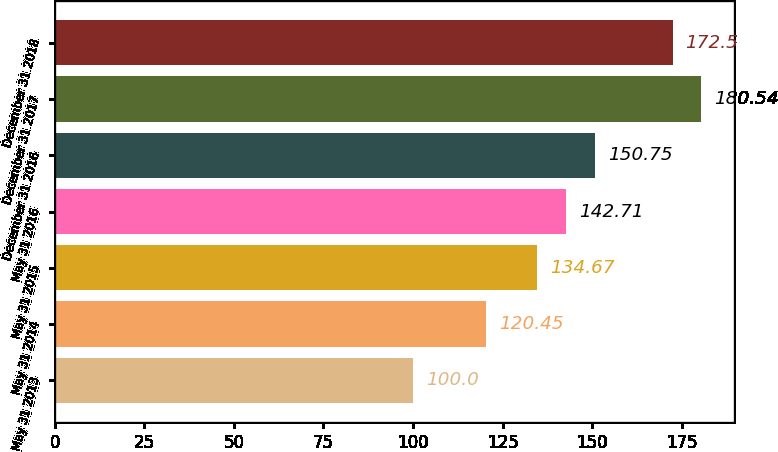<chart> <loc_0><loc_0><loc_500><loc_500><bar_chart><fcel>May 31 2013<fcel>May 31 2014<fcel>May 31 2015<fcel>May 31 2016<fcel>December 31 2016<fcel>December 31 2017<fcel>December 31 2018<nl><fcel>100<fcel>120.45<fcel>134.67<fcel>142.71<fcel>150.75<fcel>180.54<fcel>172.5<nl></chart> 